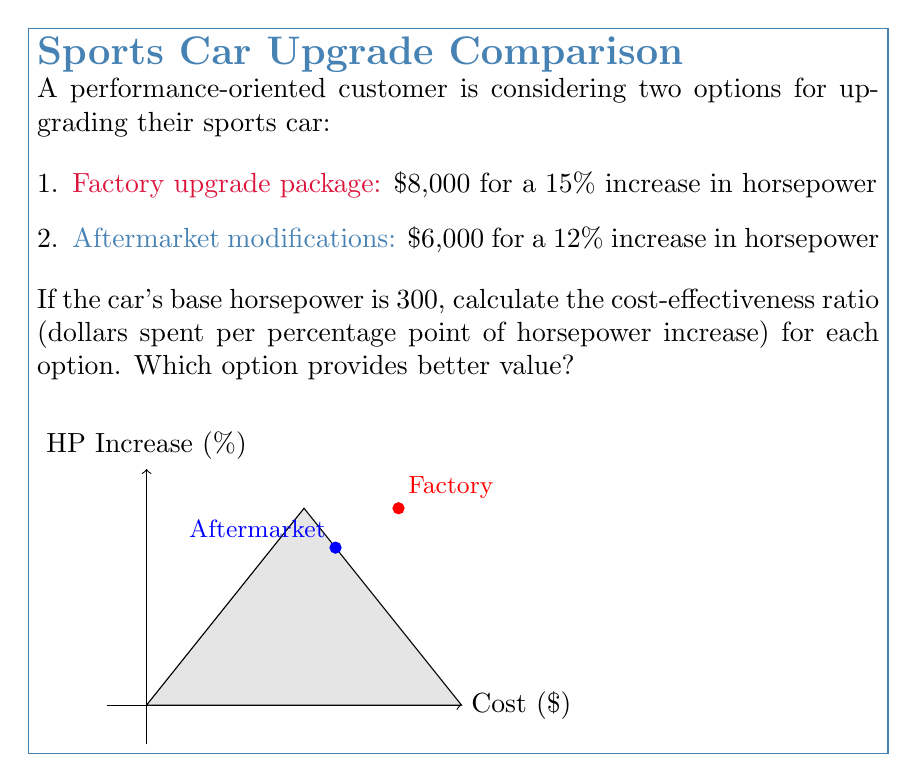Can you answer this question? Let's approach this step-by-step:

1. Calculate the horsepower increase for each option:
   Factory: 15% of 300 HP = $0.15 \times 300 = 45$ HP
   Aftermarket: 12% of 300 HP = $0.12 \times 300 = 36$ HP

2. Calculate the cost-effectiveness ratio for each option:
   
   Cost-effectiveness ratio = $\frac{\text{Cost}}{\text{Percentage increase}}$

   Factory: $$\frac{\$8,000}{15\%} = \frac{8000}{15} = \$533.33 \text{ per percentage point}$$

   Aftermarket: $$\frac{\$6,000}{12\%} = \frac{6000}{12} = \$500 \text{ per percentage point}$$

3. Compare the ratios:
   The aftermarket option has a lower cost per percentage point of horsepower increase ($500 vs $533.33), indicating better cost-effectiveness.

4. Calculate the difference in cost-effectiveness:
   $$\$533.33 - \$500 = \$33.33 \text{ per percentage point}$$
   The aftermarket option is $33.33 per percentage point more cost-effective.
Answer: Aftermarket modifications are more cost-effective by $33.33 per percentage point of horsepower increase. 